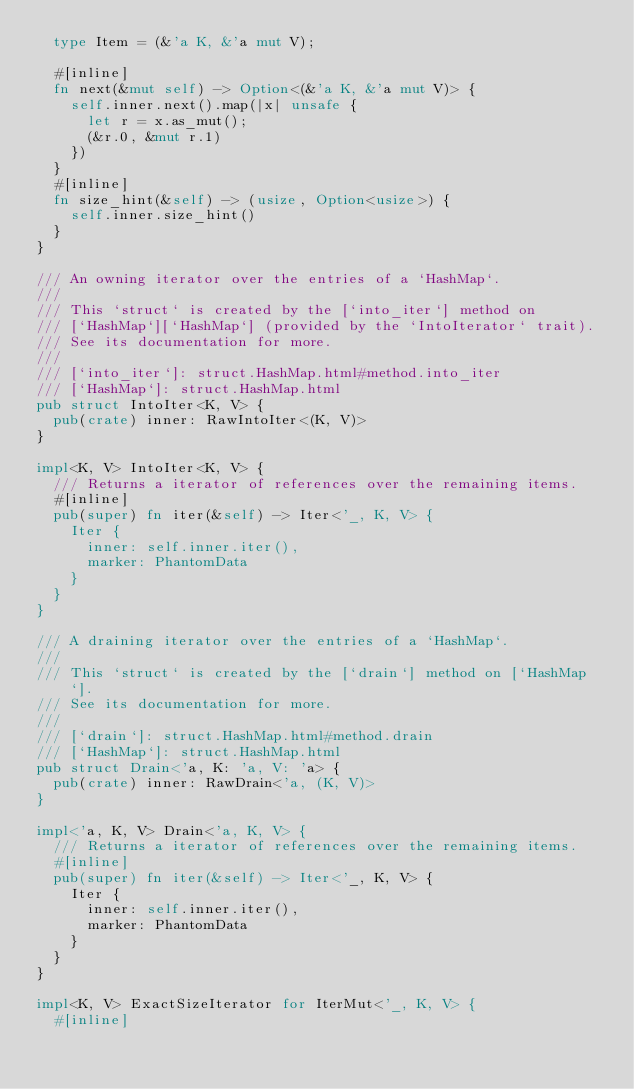Convert code to text. <code><loc_0><loc_0><loc_500><loc_500><_Rust_>  type Item = (&'a K, &'a mut V);

  #[inline]
  fn next(&mut self) -> Option<(&'a K, &'a mut V)> {
    self.inner.next().map(|x| unsafe {
      let r = x.as_mut();
      (&r.0, &mut r.1)
    })
  }
  #[inline]
  fn size_hint(&self) -> (usize, Option<usize>) {
    self.inner.size_hint()
  }
}

/// An owning iterator over the entries of a `HashMap`.
///
/// This `struct` is created by the [`into_iter`] method on
/// [`HashMap`][`HashMap`] (provided by the `IntoIterator` trait).
/// See its documentation for more.
///
/// [`into_iter`]: struct.HashMap.html#method.into_iter
/// [`HashMap`]: struct.HashMap.html
pub struct IntoIter<K, V> {
  pub(crate) inner: RawIntoIter<(K, V)>
}

impl<K, V> IntoIter<K, V> {
  /// Returns a iterator of references over the remaining items.
  #[inline]
  pub(super) fn iter(&self) -> Iter<'_, K, V> {
    Iter {
      inner: self.inner.iter(),
      marker: PhantomData
    }
  }
}

/// A draining iterator over the entries of a `HashMap`.
///
/// This `struct` is created by the [`drain`] method on [`HashMap`].
/// See its documentation for more.
///
/// [`drain`]: struct.HashMap.html#method.drain
/// [`HashMap`]: struct.HashMap.html
pub struct Drain<'a, K: 'a, V: 'a> {
  pub(crate) inner: RawDrain<'a, (K, V)>
}

impl<'a, K, V> Drain<'a, K, V> {
  /// Returns a iterator of references over the remaining items.
  #[inline]
  pub(super) fn iter(&self) -> Iter<'_, K, V> {
    Iter {
      inner: self.inner.iter(),
      marker: PhantomData
    }
  }
}

impl<K, V> ExactSizeIterator for IterMut<'_, K, V> {
  #[inline]</code> 